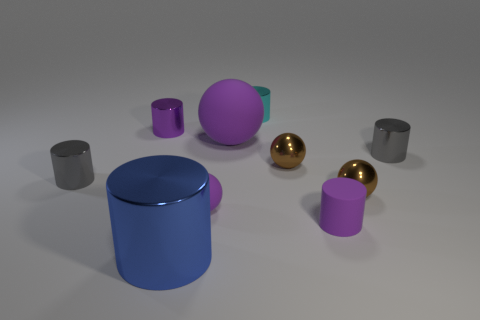Are there an equal number of small gray metal cylinders in front of the big cylinder and small purple things?
Ensure brevity in your answer.  No. What number of other blue metallic objects are the same shape as the blue metallic thing?
Your response must be concise. 0. Is the purple shiny thing the same shape as the blue thing?
Your answer should be compact. Yes. How many objects are big things that are behind the big blue thing or brown objects?
Provide a succinct answer. 3. What shape is the gray thing that is on the left side of the gray metal cylinder that is to the right of the tiny gray cylinder left of the purple shiny object?
Give a very brief answer. Cylinder. There is a purple object that is made of the same material as the cyan thing; what is its shape?
Your answer should be very brief. Cylinder. What is the size of the blue thing?
Your response must be concise. Large. Is the cyan cylinder the same size as the blue thing?
Make the answer very short. No. What number of things are small balls on the right side of the cyan metallic thing or purple cylinders that are right of the blue cylinder?
Your response must be concise. 3. How many purple matte objects are in front of the gray thing right of the big blue metallic cylinder in front of the large purple matte ball?
Ensure brevity in your answer.  2. 